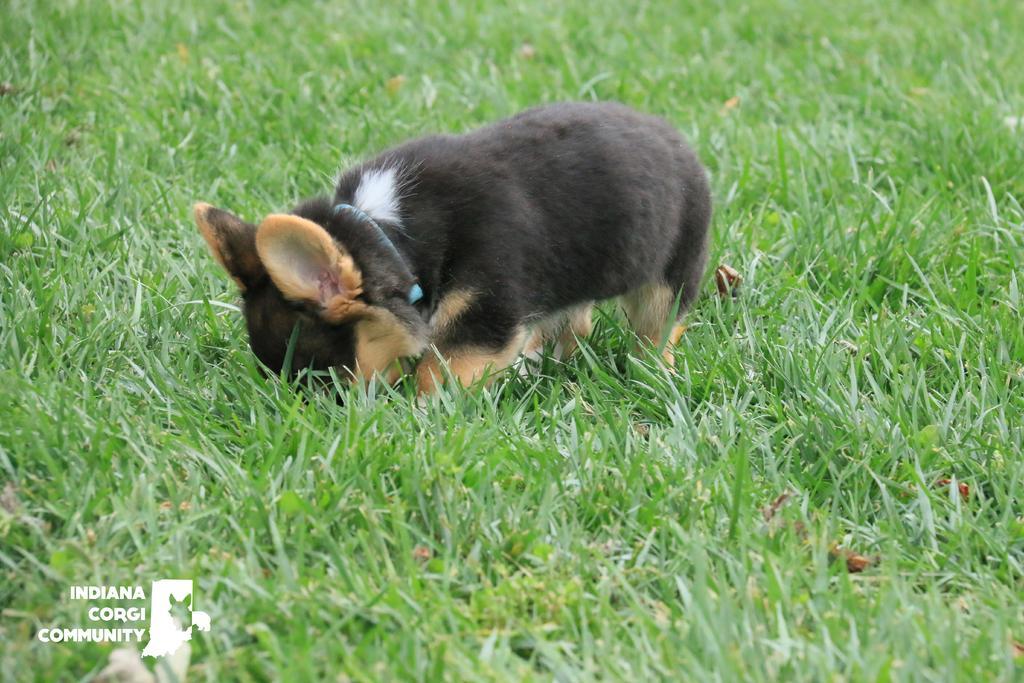Please provide a concise description of this image. In this picture we can see one dog standing on the grass. 